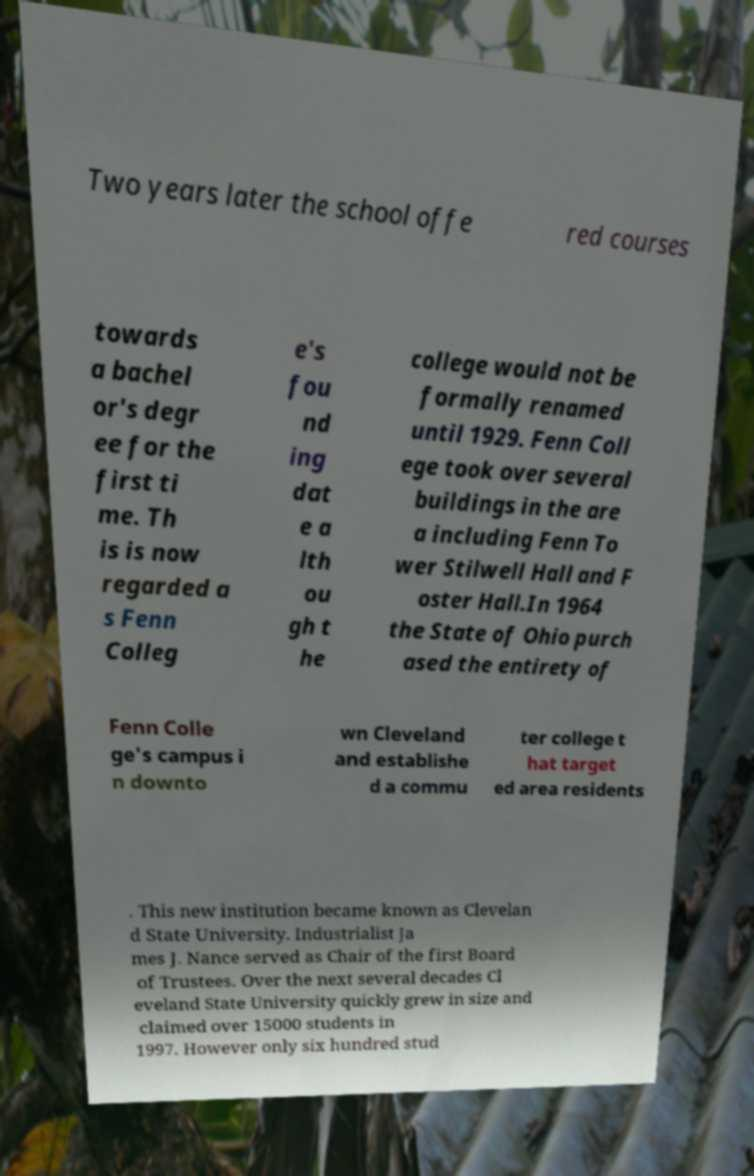Could you extract and type out the text from this image? Two years later the school offe red courses towards a bachel or's degr ee for the first ti me. Th is is now regarded a s Fenn Colleg e's fou nd ing dat e a lth ou gh t he college would not be formally renamed until 1929. Fenn Coll ege took over several buildings in the are a including Fenn To wer Stilwell Hall and F oster Hall.In 1964 the State of Ohio purch ased the entirety of Fenn Colle ge's campus i n downto wn Cleveland and establishe d a commu ter college t hat target ed area residents . This new institution became known as Clevelan d State University. Industrialist Ja mes J. Nance served as Chair of the first Board of Trustees. Over the next several decades Cl eveland State University quickly grew in size and claimed over 15000 students in 1997. However only six hundred stud 